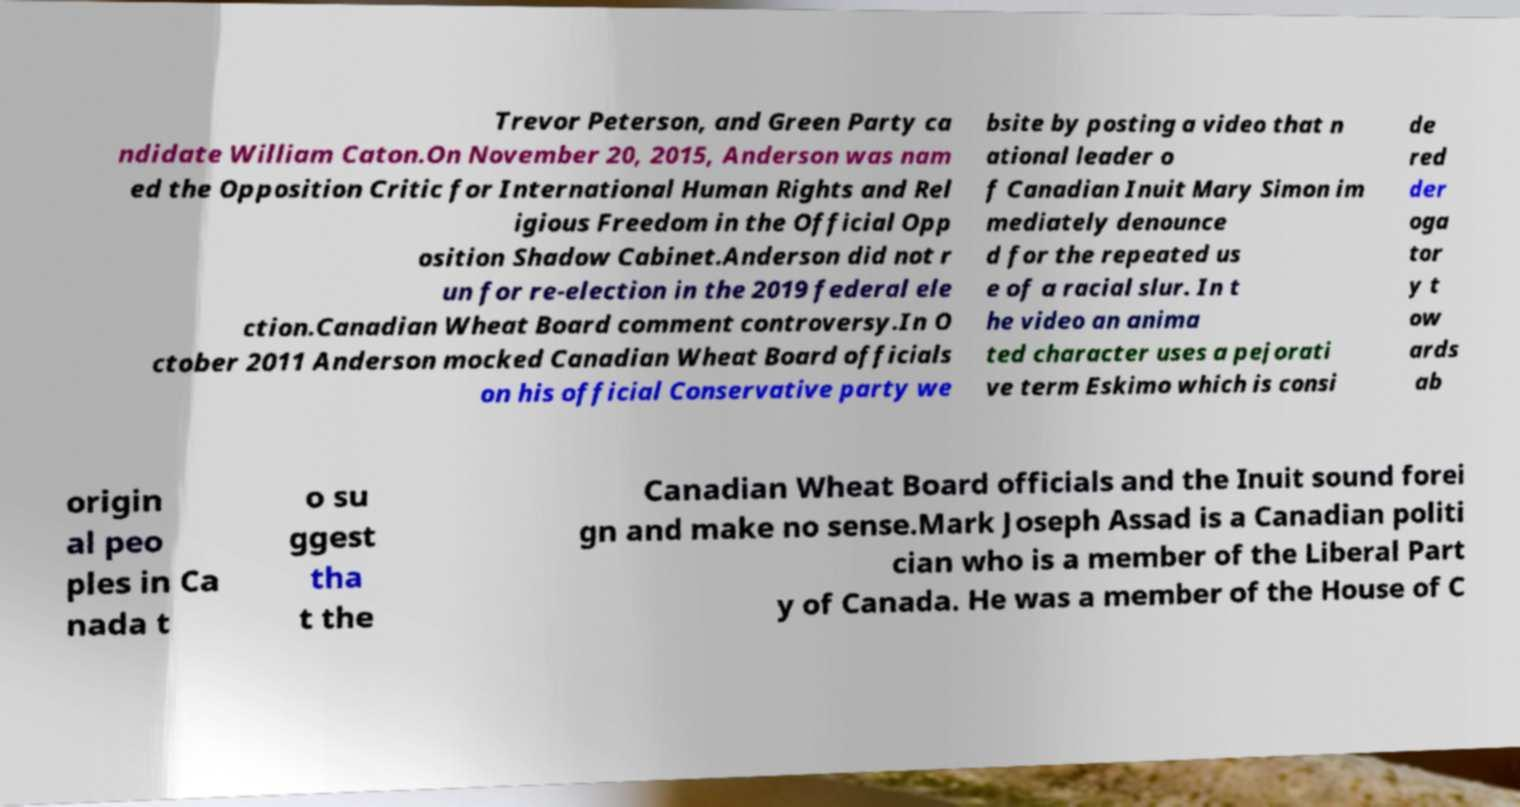There's text embedded in this image that I need extracted. Can you transcribe it verbatim? Trevor Peterson, and Green Party ca ndidate William Caton.On November 20, 2015, Anderson was nam ed the Opposition Critic for International Human Rights and Rel igious Freedom in the Official Opp osition Shadow Cabinet.Anderson did not r un for re-election in the 2019 federal ele ction.Canadian Wheat Board comment controversy.In O ctober 2011 Anderson mocked Canadian Wheat Board officials on his official Conservative party we bsite by posting a video that n ational leader o f Canadian Inuit Mary Simon im mediately denounce d for the repeated us e of a racial slur. In t he video an anima ted character uses a pejorati ve term Eskimo which is consi de red der oga tor y t ow ards ab origin al peo ples in Ca nada t o su ggest tha t the Canadian Wheat Board officials and the Inuit sound forei gn and make no sense.Mark Joseph Assad is a Canadian politi cian who is a member of the Liberal Part y of Canada. He was a member of the House of C 